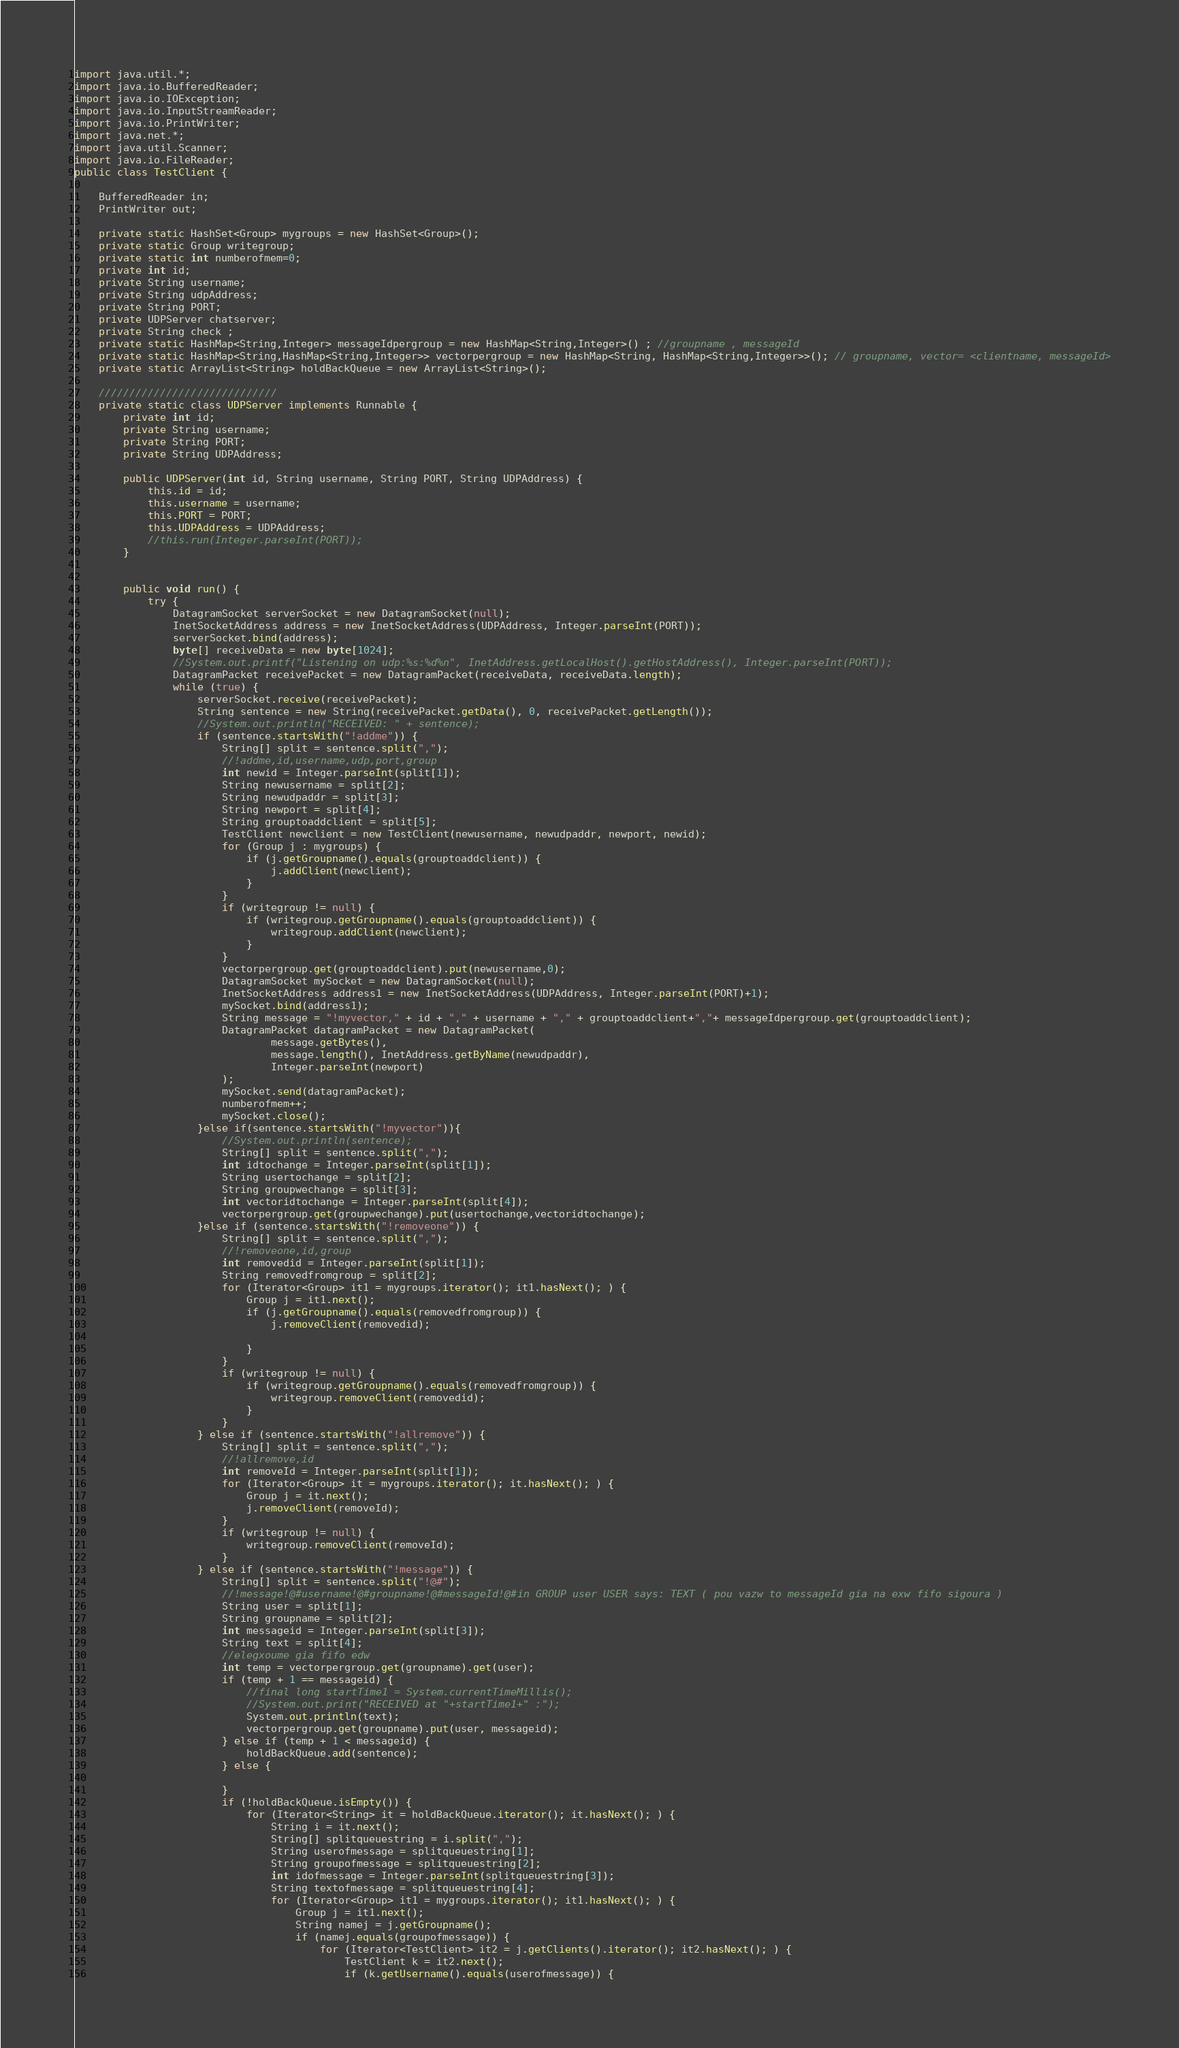Convert code to text. <code><loc_0><loc_0><loc_500><loc_500><_Java_>import java.util.*;
import java.io.BufferedReader;
import java.io.IOException;
import java.io.InputStreamReader;
import java.io.PrintWriter;
import java.net.*;
import java.util.Scanner;
import java.io.FileReader;
public class TestClient {

    BufferedReader in;
    PrintWriter out;

    private static HashSet<Group> mygroups = new HashSet<Group>();
    private static Group writegroup;
    private static int numberofmem=0;
    private int id;
    private String username;
    private String udpAddress;
    private String PORT;
    private UDPServer chatserver;
    private String check ;
    private static HashMap<String,Integer> messageIdpergroup = new HashMap<String,Integer>() ; //groupname , messageId
    private static HashMap<String,HashMap<String,Integer>> vectorpergroup = new HashMap<String, HashMap<String,Integer>>(); // groupname, vector= <clientname, messageId>
    private static ArrayList<String> holdBackQueue = new ArrayList<String>();

    /////////////////////////////
    private static class UDPServer implements Runnable {
        private int id;
        private String username;
        private String PORT;
        private String UDPAddress;

        public UDPServer(int id, String username, String PORT, String UDPAddress) {
            this.id = id;
            this.username = username;
            this.PORT = PORT;
            this.UDPAddress = UDPAddress;
            //this.run(Integer.parseInt(PORT));
        }


        public void run() {
            try {
                DatagramSocket serverSocket = new DatagramSocket(null);
                InetSocketAddress address = new InetSocketAddress(UDPAddress, Integer.parseInt(PORT));
                serverSocket.bind(address);
                byte[] receiveData = new byte[1024];
                //System.out.printf("Listening on udp:%s:%d%n", InetAddress.getLocalHost().getHostAddress(), Integer.parseInt(PORT));
                DatagramPacket receivePacket = new DatagramPacket(receiveData, receiveData.length);
                while (true) {
                    serverSocket.receive(receivePacket);
                    String sentence = new String(receivePacket.getData(), 0, receivePacket.getLength());
                    //System.out.println("RECEIVED: " + sentence);
                    if (sentence.startsWith("!addme")) {
                        String[] split = sentence.split(",");
                        //!addme,id,username,udp,port,group
                        int newid = Integer.parseInt(split[1]);
                        String newusername = split[2];
                        String newudpaddr = split[3];
                        String newport = split[4];
                        String grouptoaddclient = split[5];
                        TestClient newclient = new TestClient(newusername, newudpaddr, newport, newid);
                        for (Group j : mygroups) {
                            if (j.getGroupname().equals(grouptoaddclient)) {
                                j.addClient(newclient);
                            }
                        }
                        if (writegroup != null) {
                            if (writegroup.getGroupname().equals(grouptoaddclient)) {
                                writegroup.addClient(newclient);
                            }
                        }
                        vectorpergroup.get(grouptoaddclient).put(newusername,0);
                        DatagramSocket mySocket = new DatagramSocket(null);
                        InetSocketAddress address1 = new InetSocketAddress(UDPAddress, Integer.parseInt(PORT)+1);
                        mySocket.bind(address1);
                        String message = "!myvector," + id + "," + username + "," + grouptoaddclient+","+ messageIdpergroup.get(grouptoaddclient);
                        DatagramPacket datagramPacket = new DatagramPacket(
                                message.getBytes(),
                                message.length(), InetAddress.getByName(newudpaddr),
                                Integer.parseInt(newport)
                        );
                        mySocket.send(datagramPacket);
                        numberofmem++;
                        mySocket.close();
                    }else if(sentence.startsWith("!myvector")){
                        //System.out.println(sentence);
                        String[] split = sentence.split(",");
                        int idtochange = Integer.parseInt(split[1]);
                        String usertochange = split[2];
                        String groupwechange = split[3];
                        int vectoridtochange = Integer.parseInt(split[4]);
                        vectorpergroup.get(groupwechange).put(usertochange,vectoridtochange);
                    }else if (sentence.startsWith("!removeone")) {
                        String[] split = sentence.split(",");
                        //!removeone,id,group
                        int removedid = Integer.parseInt(split[1]);
                        String removedfromgroup = split[2];
                        for (Iterator<Group> it1 = mygroups.iterator(); it1.hasNext(); ) {
                            Group j = it1.next();
                            if (j.getGroupname().equals(removedfromgroup)) {
                                j.removeClient(removedid);

                            }
                        }
                        if (writegroup != null) {
                            if (writegroup.getGroupname().equals(removedfromgroup)) {
                                writegroup.removeClient(removedid);
                            }
                        }
                    } else if (sentence.startsWith("!allremove")) {
                        String[] split = sentence.split(",");
                        //!allremove,id
                        int removeId = Integer.parseInt(split[1]);
                        for (Iterator<Group> it = mygroups.iterator(); it.hasNext(); ) {
                            Group j = it.next();
                            j.removeClient(removeId);
                        }
                        if (writegroup != null) {
                            writegroup.removeClient(removeId);
                        }
                    } else if (sentence.startsWith("!message")) {
                        String[] split = sentence.split("!@#");
                        //!message!@#username!@#groupname!@#messageId!@#in GROUP user USER says: TEXT ( pou vazw to messageId gia na exw fifo sigoura )
                        String user = split[1];
                        String groupname = split[2];
                        int messageid = Integer.parseInt(split[3]);
                        String text = split[4];
                        //elegxoume gia fifo edw
                        int temp = vectorpergroup.get(groupname).get(user);
                        if (temp + 1 == messageid) {
                            //final long startTime1 = System.currentTimeMillis();
                            //System.out.print("RECEIVED at "+startTime1+" :");
                            System.out.println(text);
                            vectorpergroup.get(groupname).put(user, messageid);
                        } else if (temp + 1 < messageid) {
                            holdBackQueue.add(sentence);
                        } else {

                        }
                        if (!holdBackQueue.isEmpty()) {
                            for (Iterator<String> it = holdBackQueue.iterator(); it.hasNext(); ) {
                                String i = it.next();
                                String[] splitqueuestring = i.split(",");
                                String userofmessage = splitqueuestring[1];
                                String groupofmessage = splitqueuestring[2];
                                int idofmessage = Integer.parseInt(splitqueuestring[3]);
                                String textofmessage = splitqueuestring[4];
                                for (Iterator<Group> it1 = mygroups.iterator(); it1.hasNext(); ) {
                                    Group j = it1.next();
                                    String namej = j.getGroupname();
                                    if (namej.equals(groupofmessage)) {
                                        for (Iterator<TestClient> it2 = j.getClients().iterator(); it2.hasNext(); ) {
                                            TestClient k = it2.next();
                                            if (k.getUsername().equals(userofmessage)) {</code> 